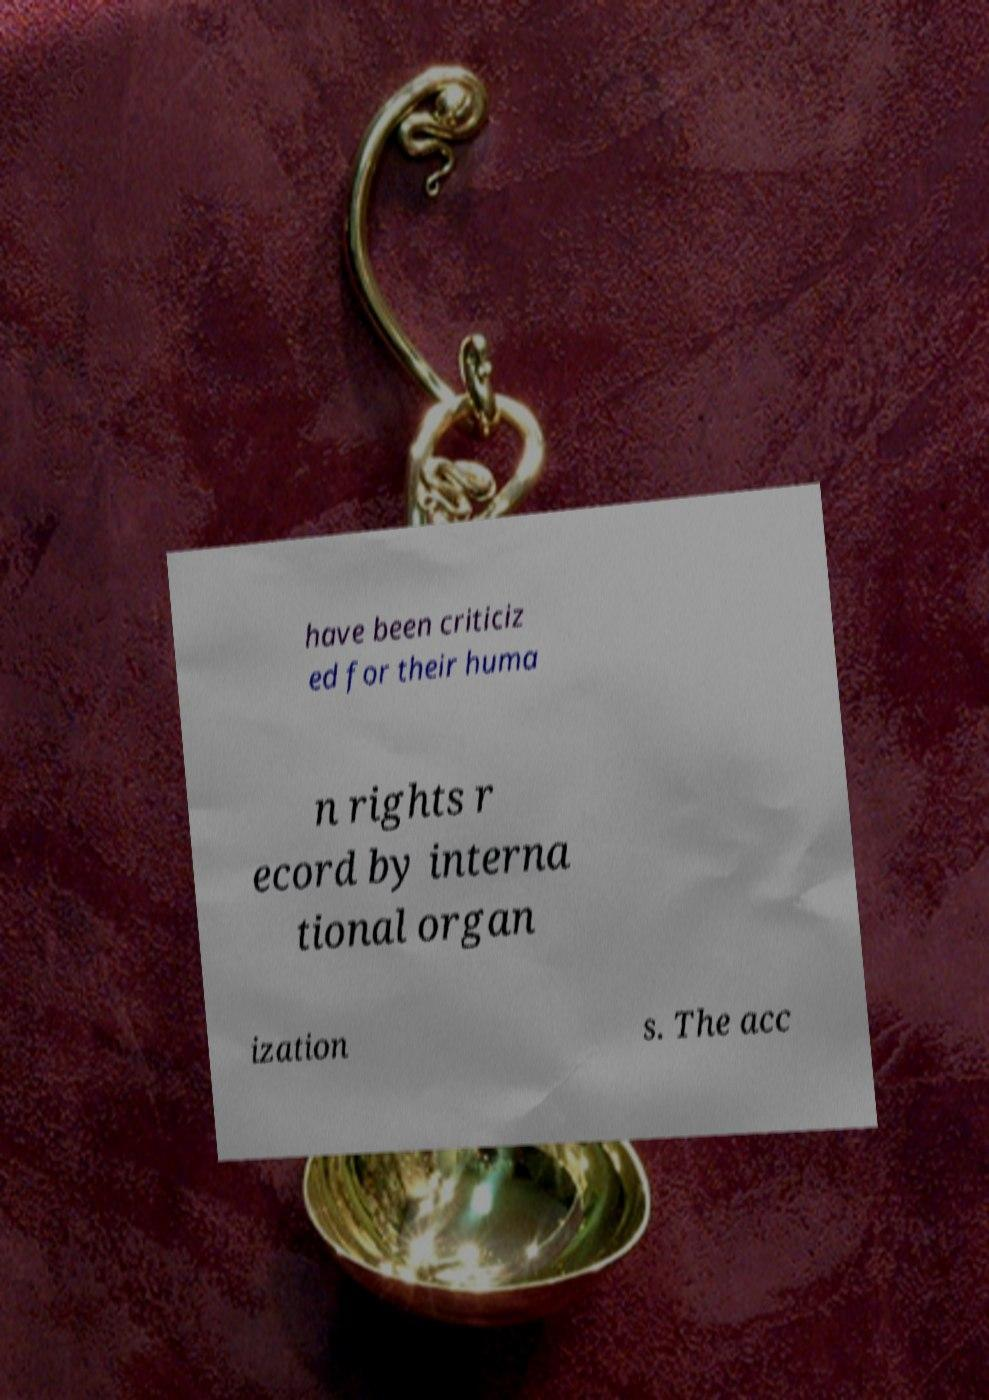Please read and relay the text visible in this image. What does it say? have been criticiz ed for their huma n rights r ecord by interna tional organ ization s. The acc 